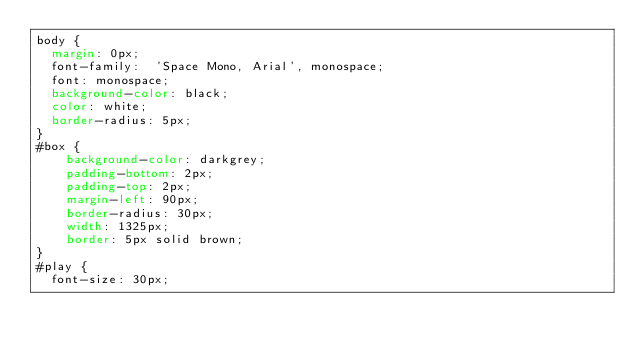Convert code to text. <code><loc_0><loc_0><loc_500><loc_500><_CSS_>body {
  margin: 0px;
  font-family:  'Space Mono, Arial', monospace;
  font: monospace;
  background-color: black;
  color: white;
  border-radius: 5px; 
}
#box {
    background-color: darkgrey;
    padding-bottom: 2px;
    padding-top: 2px;
    margin-left: 90px;
    border-radius: 30px;
    width: 1325px;
    border: 5px solid brown;
}
#play {
  font-size: 30px;</code> 